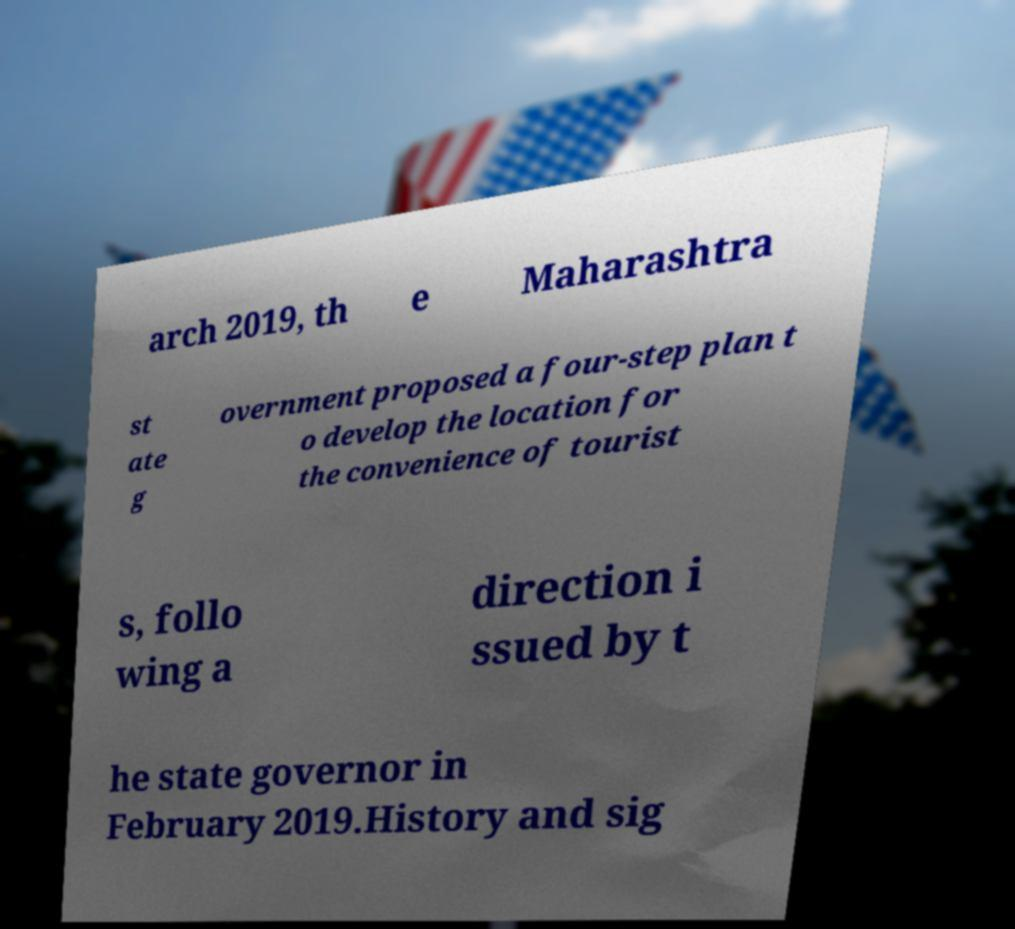Could you assist in decoding the text presented in this image and type it out clearly? arch 2019, th e Maharashtra st ate g overnment proposed a four-step plan t o develop the location for the convenience of tourist s, follo wing a direction i ssued by t he state governor in February 2019.History and sig 